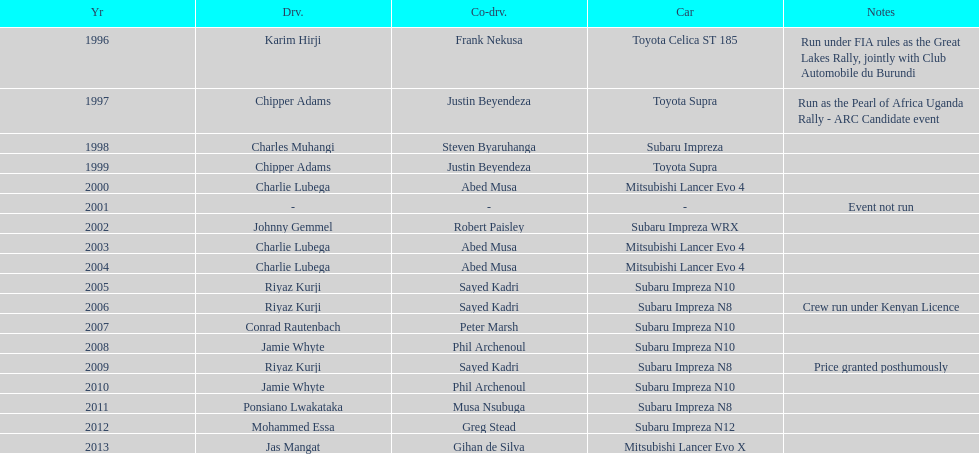How many times was charlie lubega a driver? 3. 